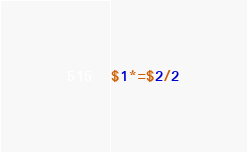<code> <loc_0><loc_0><loc_500><loc_500><_Awk_>$1*=$2/2</code> 